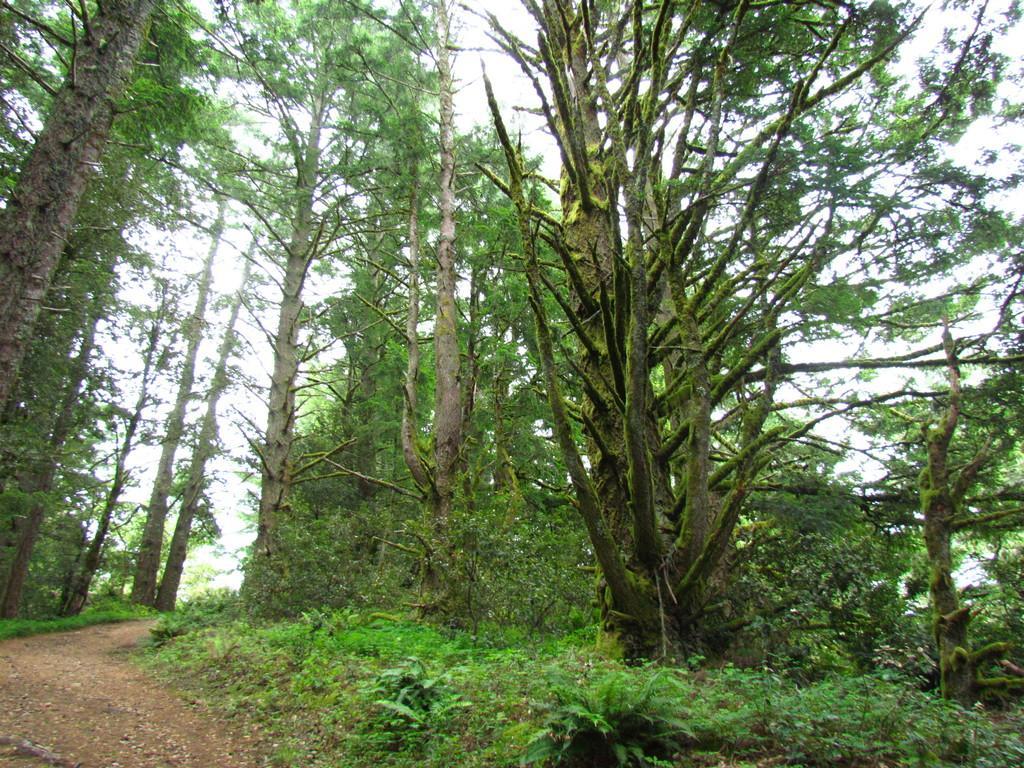In one or two sentences, can you explain what this image depicts? In this image in front there is a road. At the bottom of the image there is grass on the surface. In the background there are trees and sky. 